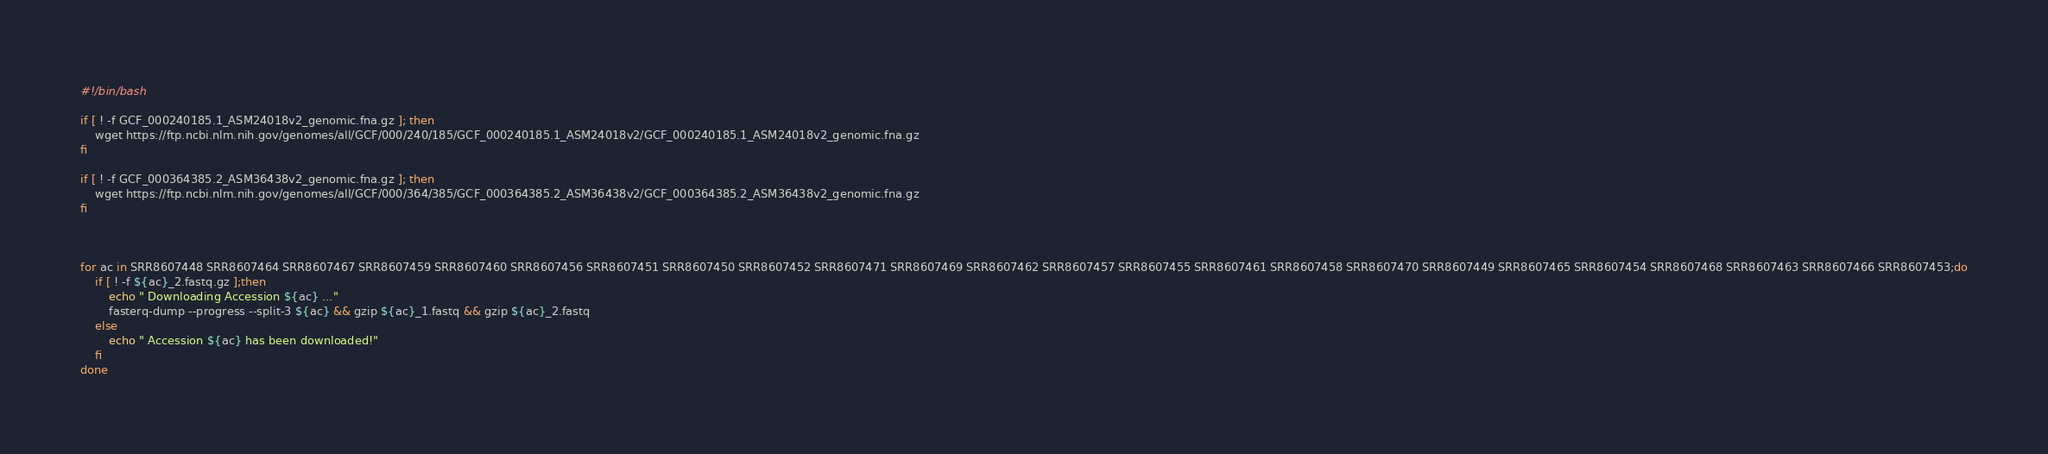<code> <loc_0><loc_0><loc_500><loc_500><_Bash_>#!/bin/bash

if [ ! -f GCF_000240185.1_ASM24018v2_genomic.fna.gz ]; then
    wget https://ftp.ncbi.nlm.nih.gov/genomes/all/GCF/000/240/185/GCF_000240185.1_ASM24018v2/GCF_000240185.1_ASM24018v2_genomic.fna.gz
fi

if [ ! -f GCF_000364385.2_ASM36438v2_genomic.fna.gz ]; then
    wget https://ftp.ncbi.nlm.nih.gov/genomes/all/GCF/000/364/385/GCF_000364385.2_ASM36438v2/GCF_000364385.2_ASM36438v2_genomic.fna.gz
fi



for ac in SRR8607448 SRR8607464 SRR8607467 SRR8607459 SRR8607460 SRR8607456 SRR8607451 SRR8607450 SRR8607452 SRR8607471 SRR8607469 SRR8607462 SRR8607457 SRR8607455 SRR8607461 SRR8607458 SRR8607470 SRR8607449 SRR8607465 SRR8607454 SRR8607468 SRR8607463 SRR8607466 SRR8607453;do
    if [ ! -f ${ac}_2.fastq.gz ];then
        echo " Downloading Accession ${ac} ..."
        fasterq-dump --progress --split-3 ${ac} && gzip ${ac}_1.fastq && gzip ${ac}_2.fastq
    else
        echo " Accession ${ac} has been downloaded!"
    fi
done




</code> 